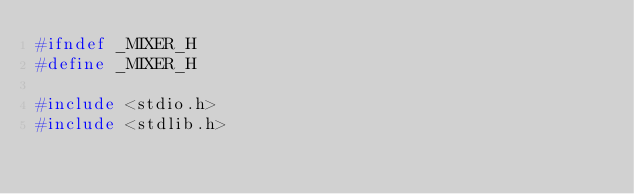<code> <loc_0><loc_0><loc_500><loc_500><_C_>#ifndef _MIXER_H
#define _MIXER_H

#include <stdio.h>
#include <stdlib.h></code> 